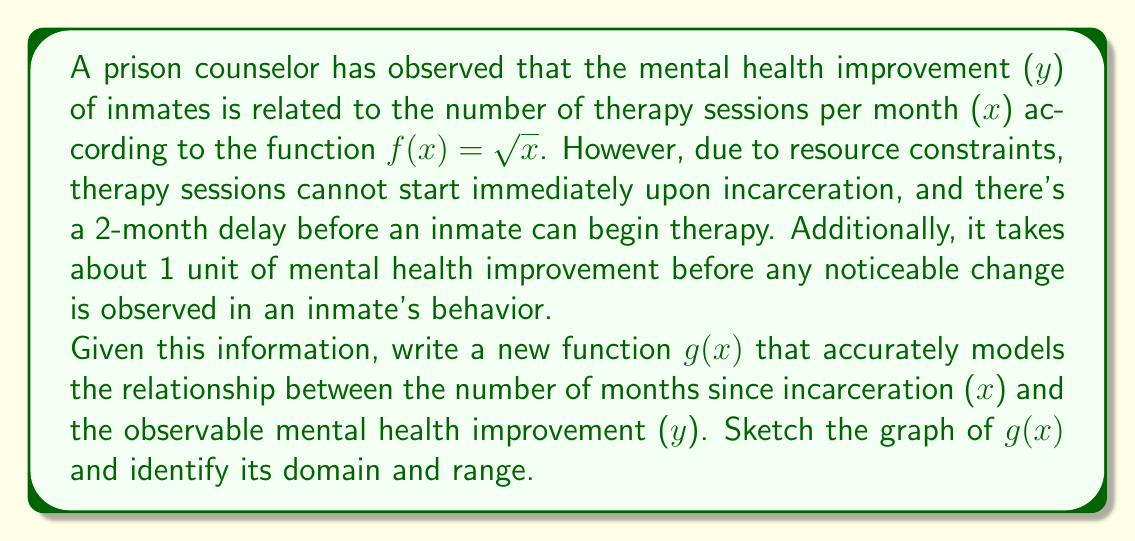Provide a solution to this math problem. To model this situation, we need to apply two transformations to the original function $f(x) = \sqrt{x}$:

1. A horizontal shift of 2 units to the right to account for the 2-month delay before therapy can begin.
2. A vertical shift of 1 unit up to account for the threshold of observable improvement.

Let's apply these transformations step by step:

1. Horizontal shift: $f(x-2)$
   This shifts the function 2 units to the right.

2. Vertical shift: $f(x-2) + 1$
   This shifts the function 1 unit up.

Therefore, the new function g(x) is:

$g(x) = f(x-2) + 1 = \sqrt{x-2} + 1$

To determine the domain and range:

Domain:
The expression under the square root must be non-negative:
$x - 2 \geq 0$
$x \geq 2$

So, the domain is $[2,\infty)$, meaning x can be any real number greater than or equal to 2.

Range:
The smallest value of $\sqrt{x-2}$ is 0 (when x = 2).
So, the smallest value of $g(x)$ is $0 + 1 = 1$.
There is no upper limit to the function.

Therefore, the range is $[1,\infty)$, meaning y can be any real number greater than or equal to 1.

The graph of g(x) would look like this:

[asy]
import graph;
size(200,200);
real f(real x) {return sqrt(max(x-2,0))+1;}
draw(graph(f,0,10),blue);
xaxis("x",arrow=Arrow);
yaxis("y",arrow=Arrow);
label("g(x)",(-0.5,f(4)),SW);
draw((2,0)--(2,1),dashed);
draw((0,1)--(2,1),dashed);
label("(2,1)",(2,1),SE);
[/asy]
Answer: $g(x) = \sqrt{x-2} + 1$, with domain $[2,\infty)$ and range $[1,\infty)$ 